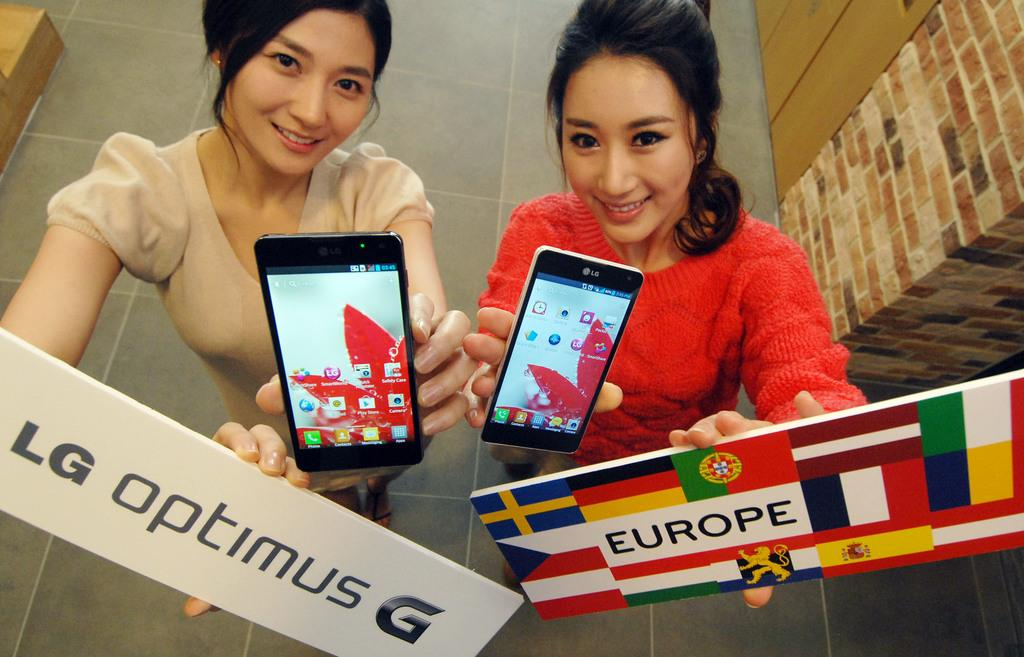<image>
Give a short and clear explanation of the subsequent image. Two women holding phones carrying signs, one of which says EUROPE. 